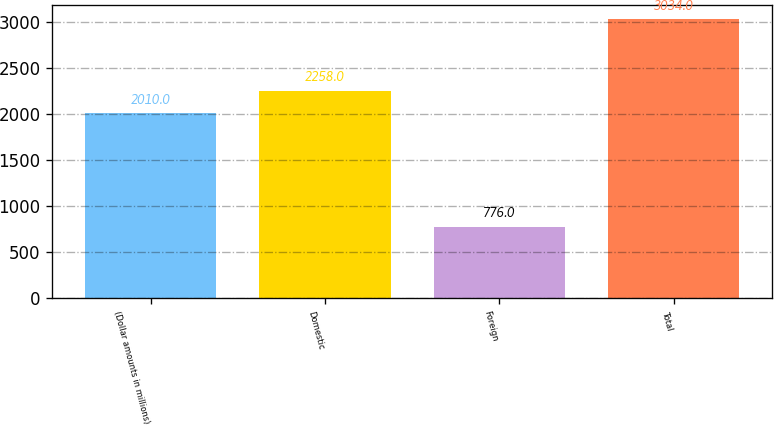<chart> <loc_0><loc_0><loc_500><loc_500><bar_chart><fcel>(Dollar amounts in millions)<fcel>Domestic<fcel>Foreign<fcel>Total<nl><fcel>2010<fcel>2258<fcel>776<fcel>3034<nl></chart> 